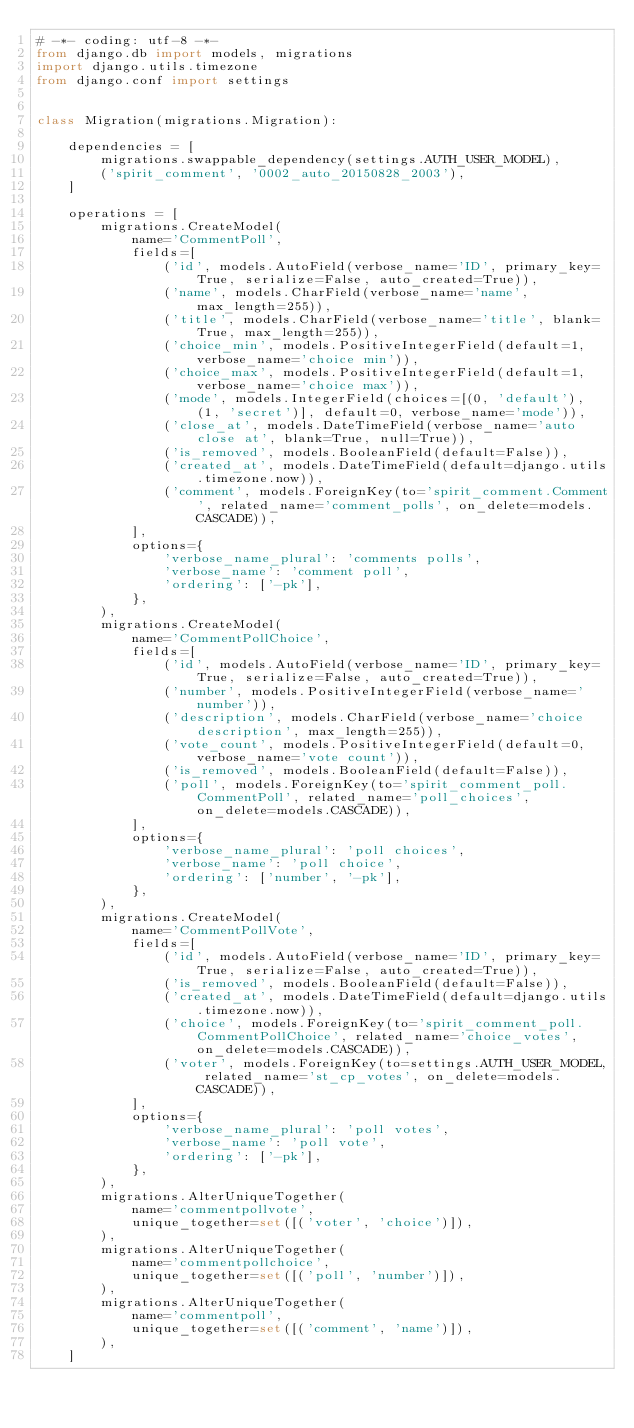Convert code to text. <code><loc_0><loc_0><loc_500><loc_500><_Python_># -*- coding: utf-8 -*-
from django.db import models, migrations
import django.utils.timezone
from django.conf import settings


class Migration(migrations.Migration):

    dependencies = [
        migrations.swappable_dependency(settings.AUTH_USER_MODEL),
        ('spirit_comment', '0002_auto_20150828_2003'),
    ]

    operations = [
        migrations.CreateModel(
            name='CommentPoll',
            fields=[
                ('id', models.AutoField(verbose_name='ID', primary_key=True, serialize=False, auto_created=True)),
                ('name', models.CharField(verbose_name='name', max_length=255)),
                ('title', models.CharField(verbose_name='title', blank=True, max_length=255)),
                ('choice_min', models.PositiveIntegerField(default=1, verbose_name='choice min')),
                ('choice_max', models.PositiveIntegerField(default=1, verbose_name='choice max')),
                ('mode', models.IntegerField(choices=[(0, 'default'), (1, 'secret')], default=0, verbose_name='mode')),
                ('close_at', models.DateTimeField(verbose_name='auto close at', blank=True, null=True)),
                ('is_removed', models.BooleanField(default=False)),
                ('created_at', models.DateTimeField(default=django.utils.timezone.now)),
                ('comment', models.ForeignKey(to='spirit_comment.Comment', related_name='comment_polls', on_delete=models.CASCADE)),
            ],
            options={
                'verbose_name_plural': 'comments polls',
                'verbose_name': 'comment poll',
                'ordering': ['-pk'],
            },
        ),
        migrations.CreateModel(
            name='CommentPollChoice',
            fields=[
                ('id', models.AutoField(verbose_name='ID', primary_key=True, serialize=False, auto_created=True)),
                ('number', models.PositiveIntegerField(verbose_name='number')),
                ('description', models.CharField(verbose_name='choice description', max_length=255)),
                ('vote_count', models.PositiveIntegerField(default=0, verbose_name='vote count')),
                ('is_removed', models.BooleanField(default=False)),
                ('poll', models.ForeignKey(to='spirit_comment_poll.CommentPoll', related_name='poll_choices', on_delete=models.CASCADE)),
            ],
            options={
                'verbose_name_plural': 'poll choices',
                'verbose_name': 'poll choice',
                'ordering': ['number', '-pk'],
            },
        ),
        migrations.CreateModel(
            name='CommentPollVote',
            fields=[
                ('id', models.AutoField(verbose_name='ID', primary_key=True, serialize=False, auto_created=True)),
                ('is_removed', models.BooleanField(default=False)),
                ('created_at', models.DateTimeField(default=django.utils.timezone.now)),
                ('choice', models.ForeignKey(to='spirit_comment_poll.CommentPollChoice', related_name='choice_votes', on_delete=models.CASCADE)),
                ('voter', models.ForeignKey(to=settings.AUTH_USER_MODEL, related_name='st_cp_votes', on_delete=models.CASCADE)),
            ],
            options={
                'verbose_name_plural': 'poll votes',
                'verbose_name': 'poll vote',
                'ordering': ['-pk'],
            },
        ),
        migrations.AlterUniqueTogether(
            name='commentpollvote',
            unique_together=set([('voter', 'choice')]),
        ),
        migrations.AlterUniqueTogether(
            name='commentpollchoice',
            unique_together=set([('poll', 'number')]),
        ),
        migrations.AlterUniqueTogether(
            name='commentpoll',
            unique_together=set([('comment', 'name')]),
        ),
    ]
</code> 